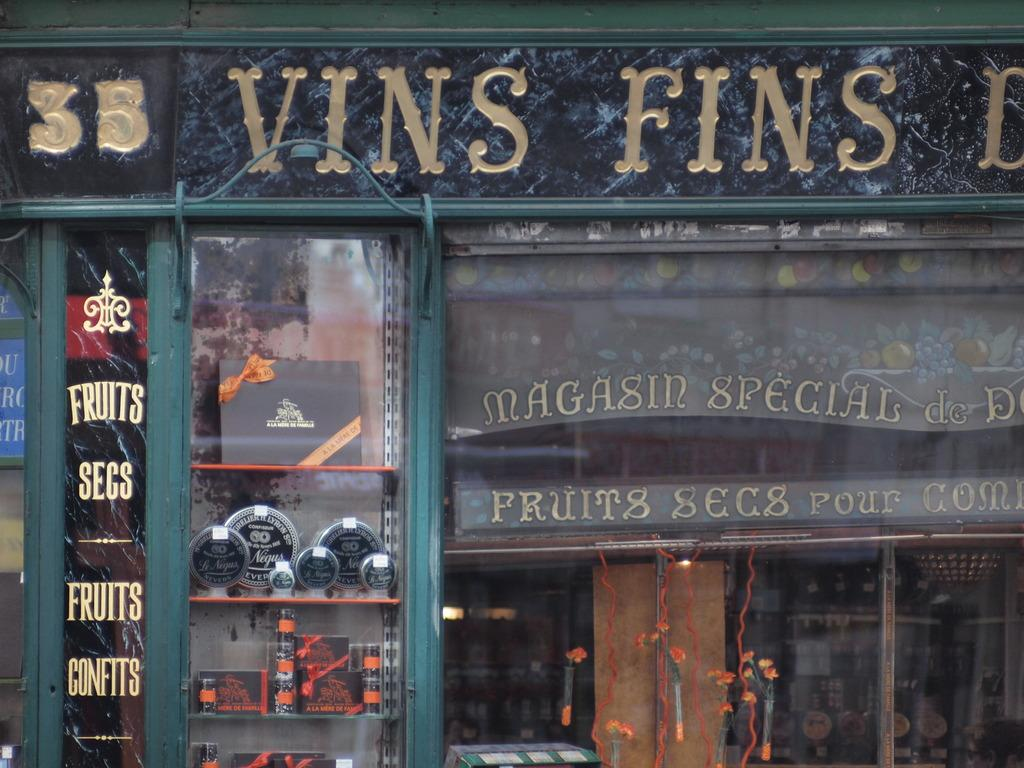What type of signage is present in the image? There are name boards in the image. What can be seen on the shelves in the image? There are shelves with objects in the image. What type of illumination is visible in the background of the image? There are lights visible in the background of the image. What else can be seen in the background of the image? There are additional objects present in the background of the image. Can you tell me how many errors are present in the image? There is no mention of any errors in the image, so it is not possible to determine the number of errors. Is there a guitar visible in the image? There is no guitar present in the image. 